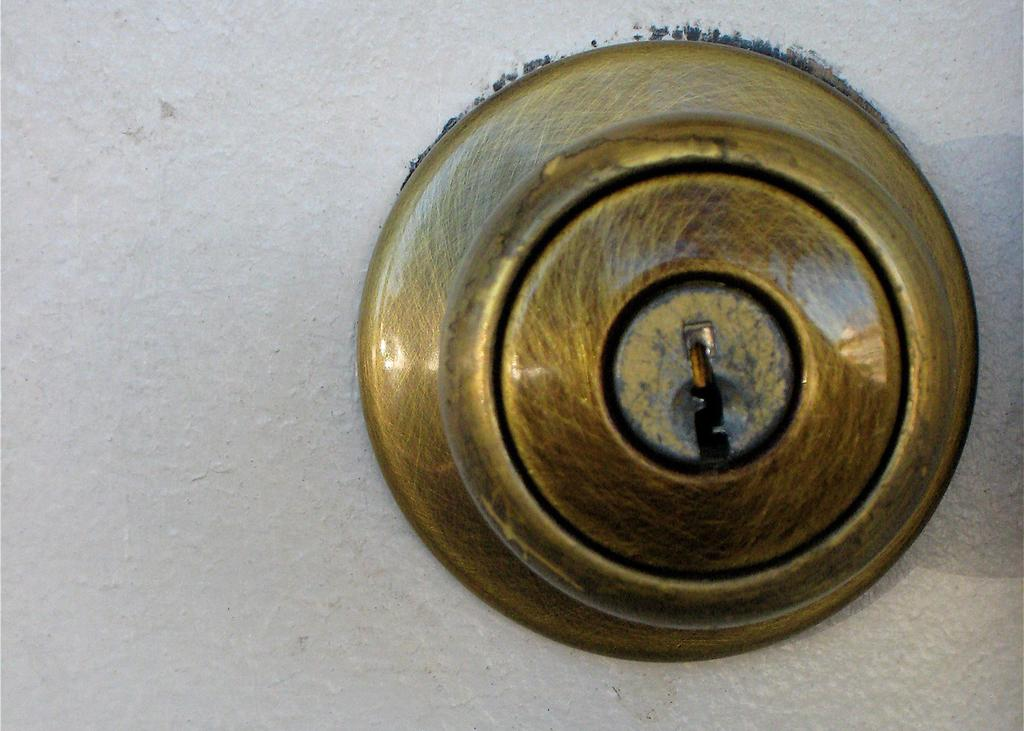What material is the object in the image made of? The object in the image is made of bronze metal. What shape is the object in the image? The object is in a spherical shape. Where is the object located in the image? The object is on a wall. What type of sweater is the father wearing in the image? There is no father or sweater present in the image; it features a bronze metal object on a wall. 